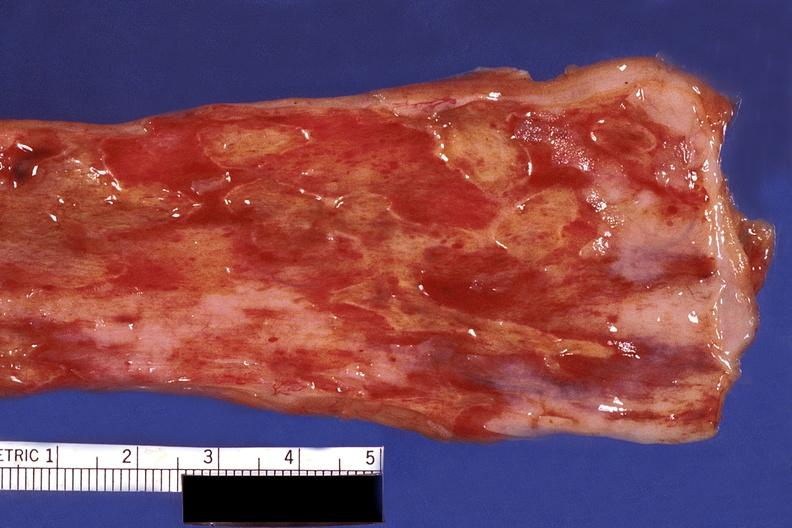where does this belong to?
Answer the question using a single word or phrase. Gastrointestinal system 